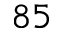<formula> <loc_0><loc_0><loc_500><loc_500>^ { 8 5 }</formula> 